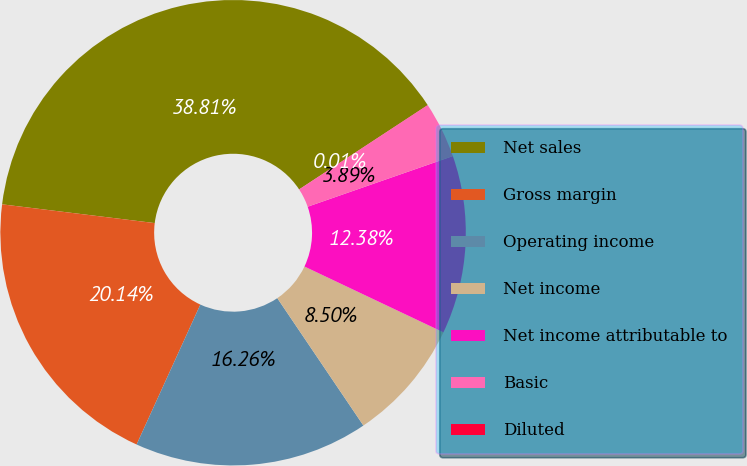Convert chart to OTSL. <chart><loc_0><loc_0><loc_500><loc_500><pie_chart><fcel>Net sales<fcel>Gross margin<fcel>Operating income<fcel>Net income<fcel>Net income attributable to<fcel>Basic<fcel>Diluted<nl><fcel>38.81%<fcel>20.14%<fcel>16.26%<fcel>8.5%<fcel>12.38%<fcel>3.89%<fcel>0.01%<nl></chart> 